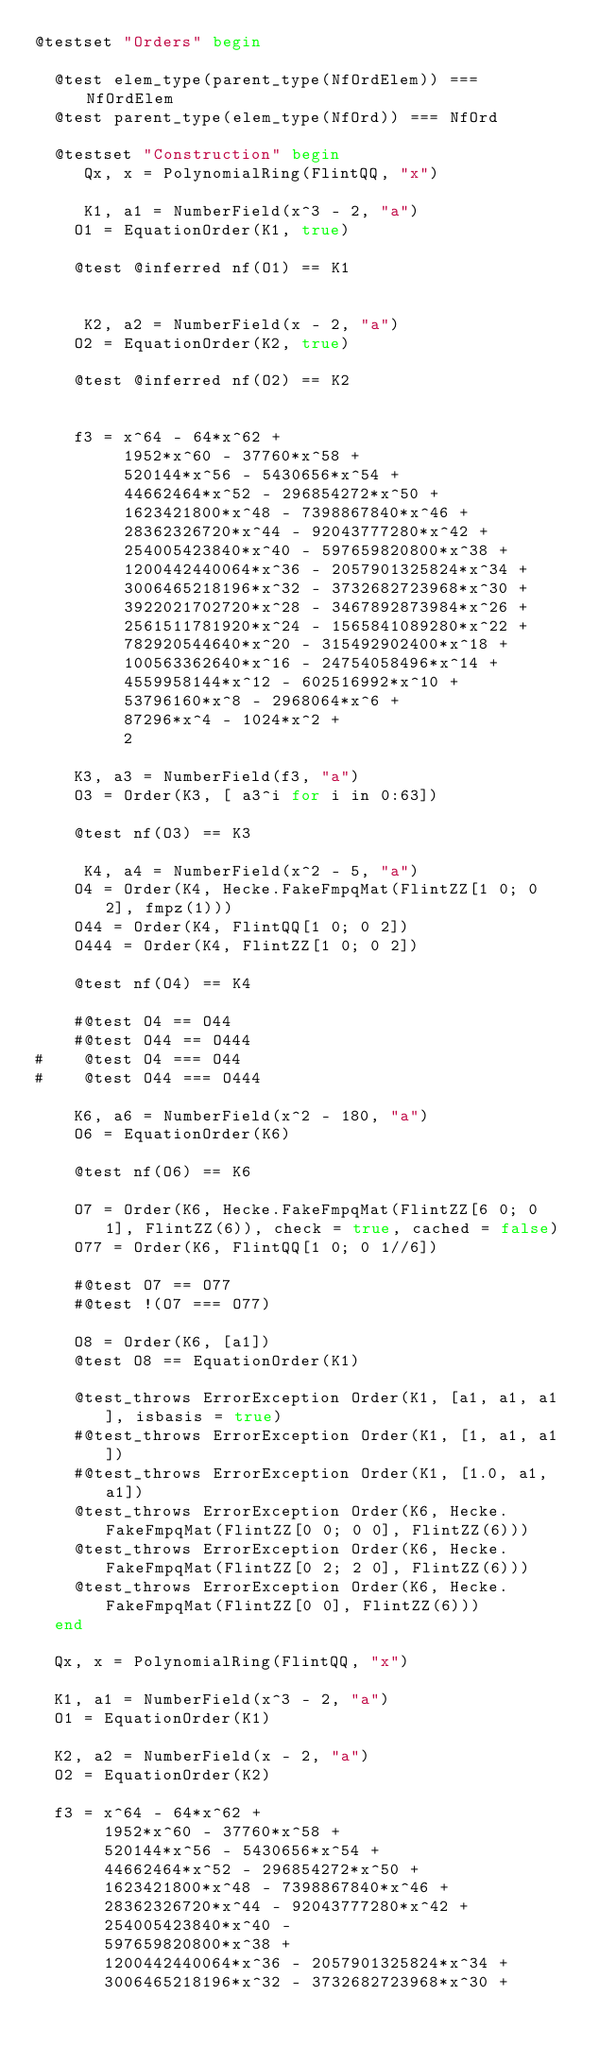Convert code to text. <code><loc_0><loc_0><loc_500><loc_500><_Julia_>@testset "Orders" begin

  @test elem_type(parent_type(NfOrdElem)) === NfOrdElem
  @test parent_type(elem_type(NfOrd)) === NfOrd

  @testset "Construction" begin
     Qx, x = PolynomialRing(FlintQQ, "x")

     K1, a1 = NumberField(x^3 - 2, "a")
    O1 = EquationOrder(K1, true)

    @test @inferred nf(O1) == K1


     K2, a2 = NumberField(x - 2, "a")
    O2 = EquationOrder(K2, true)

    @test @inferred nf(O2) == K2


    f3 = x^64 - 64*x^62 +
         1952*x^60 - 37760*x^58 +
         520144*x^56 - 5430656*x^54 +
         44662464*x^52 - 296854272*x^50 +
         1623421800*x^48 - 7398867840*x^46 +
         28362326720*x^44 - 92043777280*x^42 +
         254005423840*x^40 - 597659820800*x^38 +
         1200442440064*x^36 - 2057901325824*x^34 +
         3006465218196*x^32 - 3732682723968*x^30 +
         3922021702720*x^28 - 3467892873984*x^26 +
         2561511781920*x^24 - 1565841089280*x^22 +
         782920544640*x^20 - 315492902400*x^18 +
         100563362640*x^16 - 24754058496*x^14 +
         4559958144*x^12 - 602516992*x^10 +
         53796160*x^8 - 2968064*x^6 +
         87296*x^4 - 1024*x^2 +
         2

    K3, a3 = NumberField(f3, "a")
    O3 = Order(K3, [ a3^i for i in 0:63])

    @test nf(O3) == K3

     K4, a4 = NumberField(x^2 - 5, "a")
    O4 = Order(K4, Hecke.FakeFmpqMat(FlintZZ[1 0; 0 2], fmpz(1)))
    O44 = Order(K4, FlintQQ[1 0; 0 2])
    O444 = Order(K4, FlintZZ[1 0; 0 2])

    @test nf(O4) == K4

    #@test O4 == O44
    #@test O44 == O444
#    @test O4 === O44
#    @test O44 === O444

    K6, a6 = NumberField(x^2 - 180, "a")
    O6 = EquationOrder(K6)

    @test nf(O6) == K6

    O7 = Order(K6, Hecke.FakeFmpqMat(FlintZZ[6 0; 0 1], FlintZZ(6)), check = true, cached = false)
    O77 = Order(K6, FlintQQ[1 0; 0 1//6])

    #@test O7 == O77
    #@test !(O7 === O77)

    O8 = Order(K6, [a1])
    @test O8 == EquationOrder(K1)

    @test_throws ErrorException Order(K1, [a1, a1, a1], isbasis = true)
    #@test_throws ErrorException Order(K1, [1, a1, a1])
    #@test_throws ErrorException Order(K1, [1.0, a1, a1])
    @test_throws ErrorException Order(K6, Hecke.FakeFmpqMat(FlintZZ[0 0; 0 0], FlintZZ(6)))
    @test_throws ErrorException Order(K6, Hecke.FakeFmpqMat(FlintZZ[0 2; 2 0], FlintZZ(6)))
    @test_throws ErrorException Order(K6, Hecke.FakeFmpqMat(FlintZZ[0 0], FlintZZ(6)))
  end

  Qx, x = PolynomialRing(FlintQQ, "x")

  K1, a1 = NumberField(x^3 - 2, "a")
  O1 = EquationOrder(K1)

  K2, a2 = NumberField(x - 2, "a")
  O2 = EquationOrder(K2)

  f3 = x^64 - 64*x^62 +
       1952*x^60 - 37760*x^58 +
       520144*x^56 - 5430656*x^54 +
       44662464*x^52 - 296854272*x^50 +
       1623421800*x^48 - 7398867840*x^46 +
       28362326720*x^44 - 92043777280*x^42 +
       254005423840*x^40 -
       597659820800*x^38 +
       1200442440064*x^36 - 2057901325824*x^34 +
       3006465218196*x^32 - 3732682723968*x^30 +</code> 